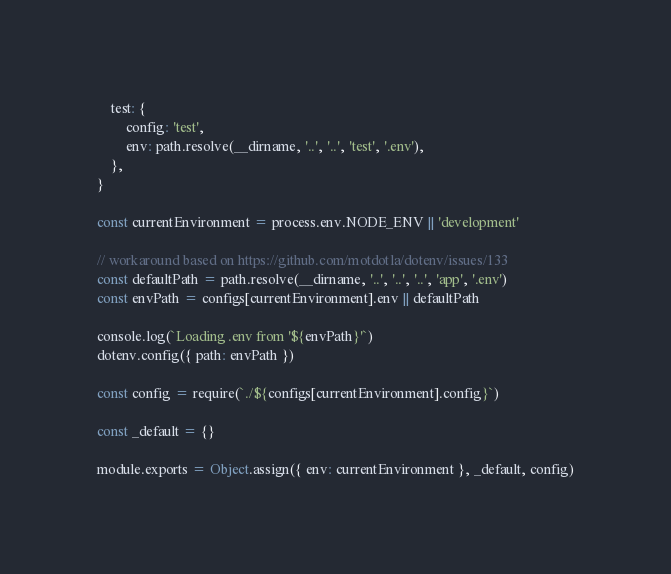Convert code to text. <code><loc_0><loc_0><loc_500><loc_500><_JavaScript_>	test: {
		config: 'test',
		env: path.resolve(__dirname, '..', '..', 'test', '.env'),
	},
}

const currentEnvironment = process.env.NODE_ENV || 'development'

// workaround based on https://github.com/motdotla/dotenv/issues/133
const defaultPath = path.resolve(__dirname, '..', '..', '..', 'app', '.env')
const envPath = configs[currentEnvironment].env || defaultPath

console.log(`Loading .env from '${envPath}'`)
dotenv.config({ path: envPath })

const config = require(`./${configs[currentEnvironment].config}`)

const _default = {}

module.exports = Object.assign({ env: currentEnvironment }, _default, config)
</code> 